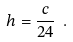Convert formula to latex. <formula><loc_0><loc_0><loc_500><loc_500>h = \frac { c } { 2 4 } \ .</formula> 